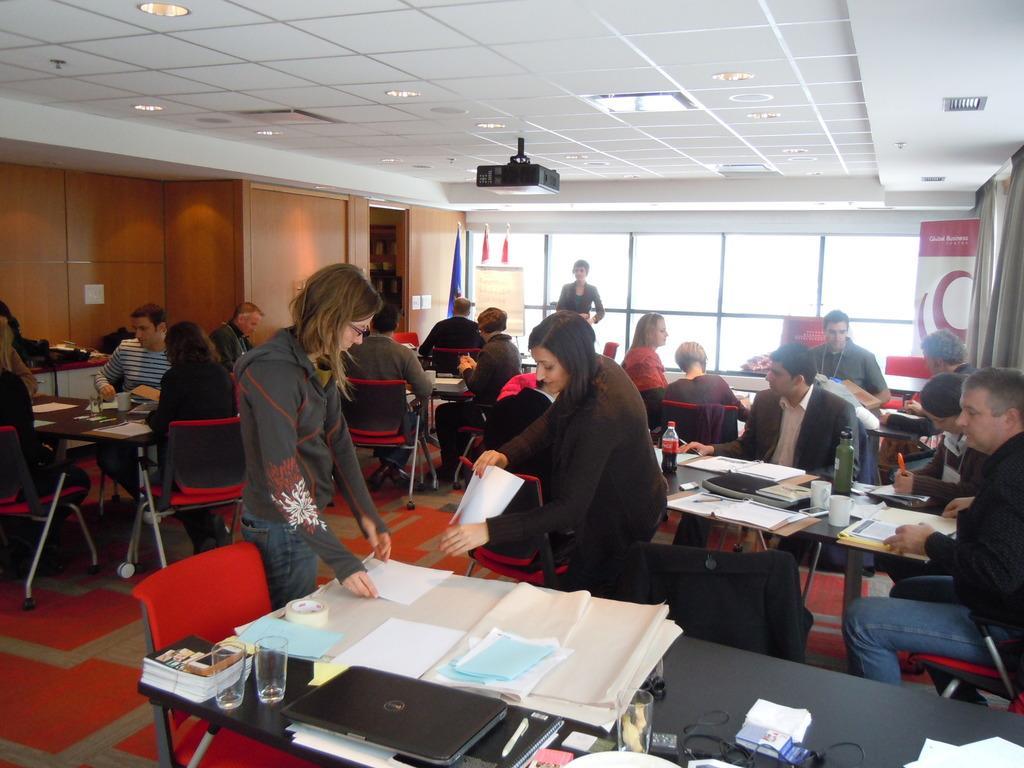Can you describe this image briefly? There are some people sitting around a table in the chairs in which some papers, laptops, glasses and some accessories were placed. There are some people standing. In the background there is a wall and a windows here. Projector is attached to the ceiling. 